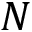<formula> <loc_0><loc_0><loc_500><loc_500>N</formula> 